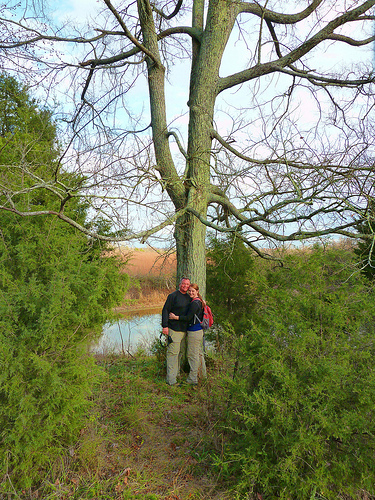<image>
Is the tree behind the man? Yes. From this viewpoint, the tree is positioned behind the man, with the man partially or fully occluding the tree. 